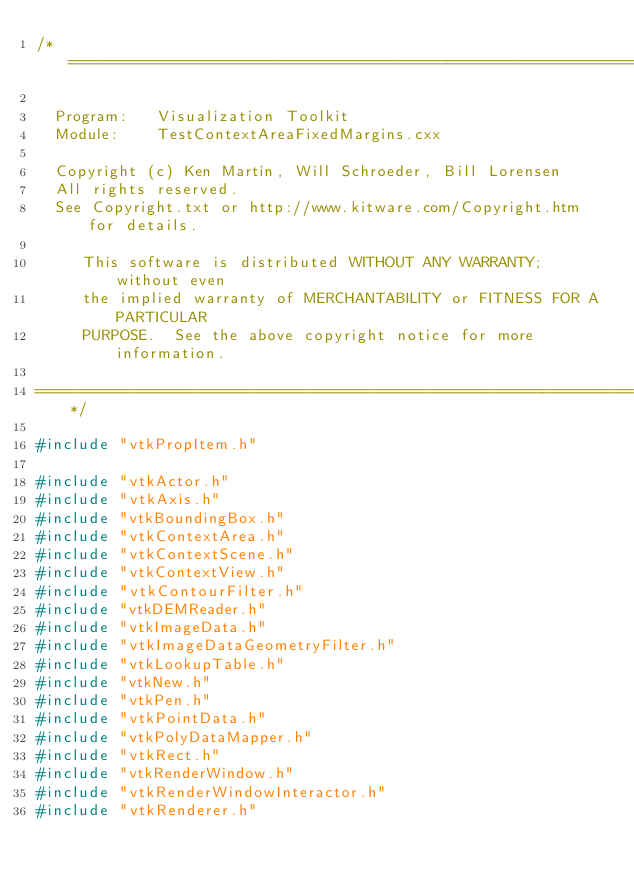Convert code to text. <code><loc_0><loc_0><loc_500><loc_500><_C++_>/*=========================================================================

  Program:   Visualization Toolkit
  Module:    TestContextAreaFixedMargins.cxx

  Copyright (c) Ken Martin, Will Schroeder, Bill Lorensen
  All rights reserved.
  See Copyright.txt or http://www.kitware.com/Copyright.htm for details.

     This software is distributed WITHOUT ANY WARRANTY; without even
     the implied warranty of MERCHANTABILITY or FITNESS FOR A PARTICULAR
     PURPOSE.  See the above copyright notice for more information.

=========================================================================*/

#include "vtkPropItem.h"

#include "vtkActor.h"
#include "vtkAxis.h"
#include "vtkBoundingBox.h"
#include "vtkContextArea.h"
#include "vtkContextScene.h"
#include "vtkContextView.h"
#include "vtkContourFilter.h"
#include "vtkDEMReader.h"
#include "vtkImageData.h"
#include "vtkImageDataGeometryFilter.h"
#include "vtkLookupTable.h"
#include "vtkNew.h"
#include "vtkPen.h"
#include "vtkPointData.h"
#include "vtkPolyDataMapper.h"
#include "vtkRect.h"
#include "vtkRenderWindow.h"
#include "vtkRenderWindowInteractor.h"
#include "vtkRenderer.h"</code> 